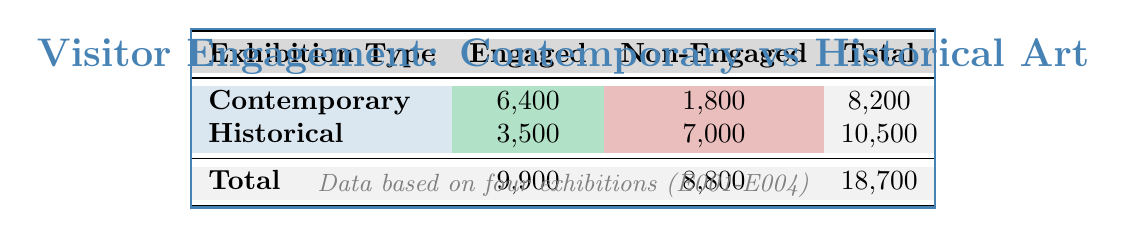What is the total number of engaged visitors in contemporary exhibitions? To find the total number of engaged visitors in contemporary exhibitions, we look at the "Engaged" column for Contemporary. We sum the values: 6,400 (engaged visitors from contemporary exhibitions) directly from the table.
Answer: 6,400 What is the total number of non-engaged visitors in historical exhibitions? To determine the total of non-engaged visitors in historical exhibitions, we look at the "Non-Engaged" column for Historical and sum the values: 7,000 (non-engaged visitors) directly from the table.
Answer: 7,000 True or False: The total number of visitors in contemporary exhibitions is higher than in historical ones. To verify this, we need to compare the total attendance for both types. Contemporary total is 8,200, while Historical total is 10,500. Since 10,500 is greater than 8,200, the statement is false.
Answer: False What is the ratio of engaged to non-engaged visitors in contemporary exhibitions? First, we see the number of engaged visitors in contemporary (6,400) and non-engaged visitors (1,800). The ratio is calculated by dividing engaged by non-engaged: 6,400 / 1,800. Simplifying this gives a ratio of approximately 3.56:1.
Answer: Approximately 3.56:1 How many more non-engaged visitors are there in historical exhibitions compared to contemporary ones? To find this difference, we first identify the number of non-engaged visitors: Historical has 7,000, while Contemporary has 1,800. The difference is calculated by subtracting contemporary non-engaged from historical non-engaged: 7,000 - 1,800 = 5,200.
Answer: 5,200 What is the overall percentage of engaged visitors across all exhibitions? To find the overall percentage of engaged visitors, we first sum up all engaged visitors (9,900) and total visitors (18,700). Then, the percentage is calculated as (9,900 / 18,700) * 100, yielding approximately 52.94%.
Answer: Approximately 52.94% Are there more total visitors in contemporary exhibitions compared to engaged visitors in historical exhibitions? First, we find the total visitors in contemporary (8,200) and engaged visitors in historical (3,500). Since 8,200 is greater than 3,500, the answer is yes.
Answer: Yes What is the total number of visitors across both contemporary exhibitions in comparison to both historical exhibitions? We add total attendance for contemporary (8,200) and historical (10,500). The sum of these totals indicates that: 8,200 + 10,500 = 18,700, which represents all visitors in the data.
Answer: 18,700 